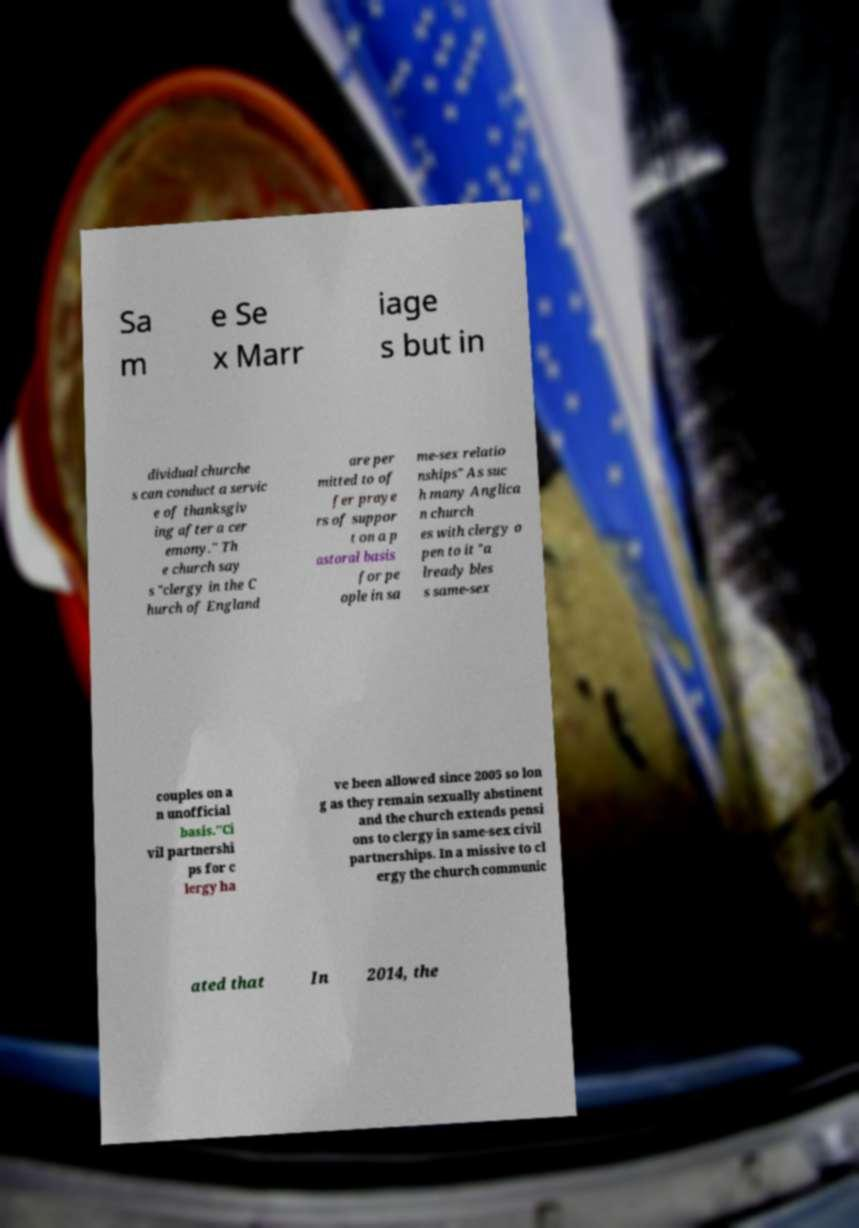There's text embedded in this image that I need extracted. Can you transcribe it verbatim? Sa m e Se x Marr iage s but in dividual churche s can conduct a servic e of thanksgiv ing after a cer emony." Th e church say s "clergy in the C hurch of England are per mitted to of fer praye rs of suppor t on a p astoral basis for pe ople in sa me-sex relatio nships" As suc h many Anglica n church es with clergy o pen to it "a lready bles s same-sex couples on a n unofficial basis."Ci vil partnershi ps for c lergy ha ve been allowed since 2005 so lon g as they remain sexually abstinent and the church extends pensi ons to clergy in same-sex civil partnerships. In a missive to cl ergy the church communic ated that In 2014, the 